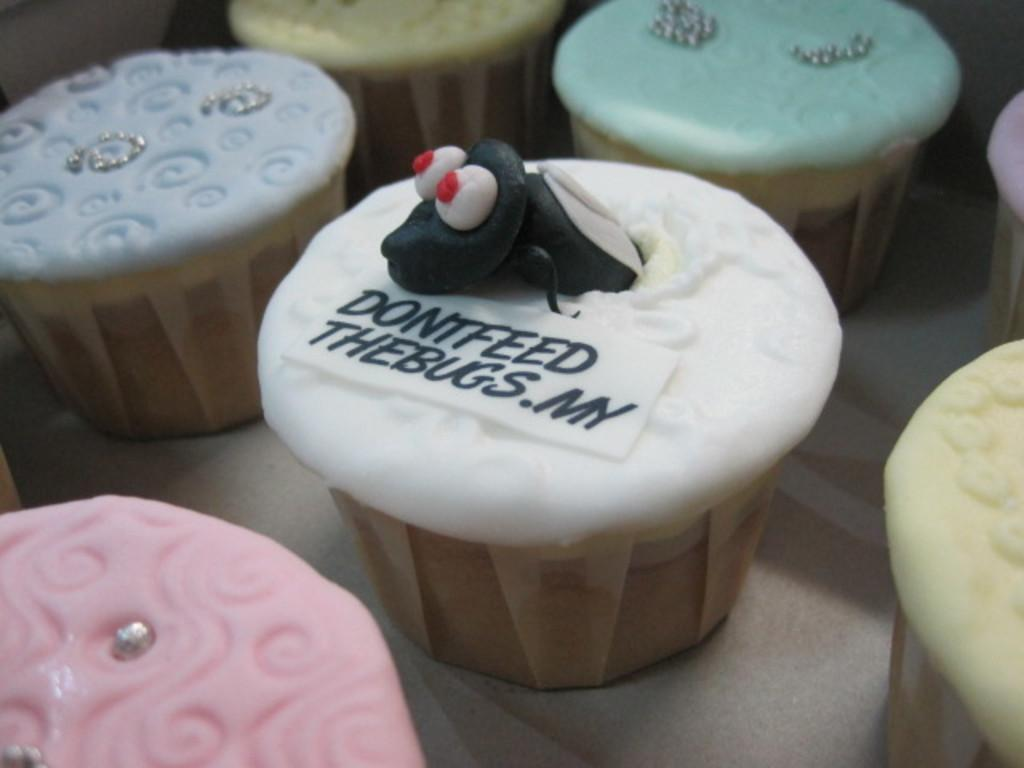What is placed on the platform in the image? There are cupcakes on a platform in the image. Can you describe the middle cupcake? The middle cupcake has a text and an insect-like structure on it. What might be the purpose of the text on the middle cupcake? The text on the middle cupcake might be a label, a message, or a decoration. What type of van can be seen parked next to the platform in the image? There is no van present in the image; it only features cupcakes on a platform. How would you describe the texture of the title on the middle cupcake? There is no title present on the middle cupcake, only text. 